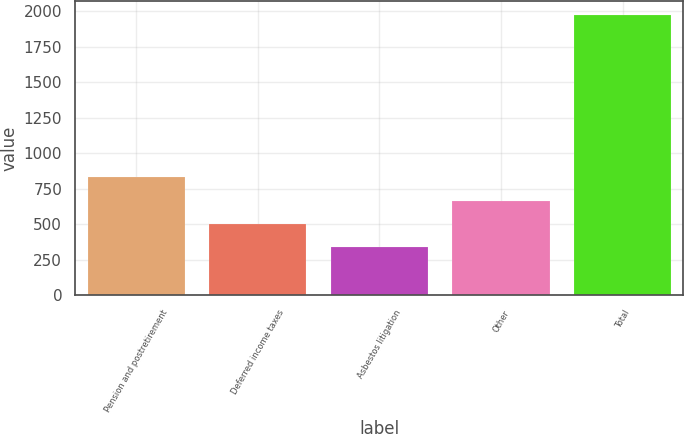Convert chart. <chart><loc_0><loc_0><loc_500><loc_500><bar_chart><fcel>Pension and postretirement<fcel>Deferred income taxes<fcel>Asbestos litigation<fcel>Other<fcel>Total<nl><fcel>830.5<fcel>503.5<fcel>340<fcel>667<fcel>1975<nl></chart> 